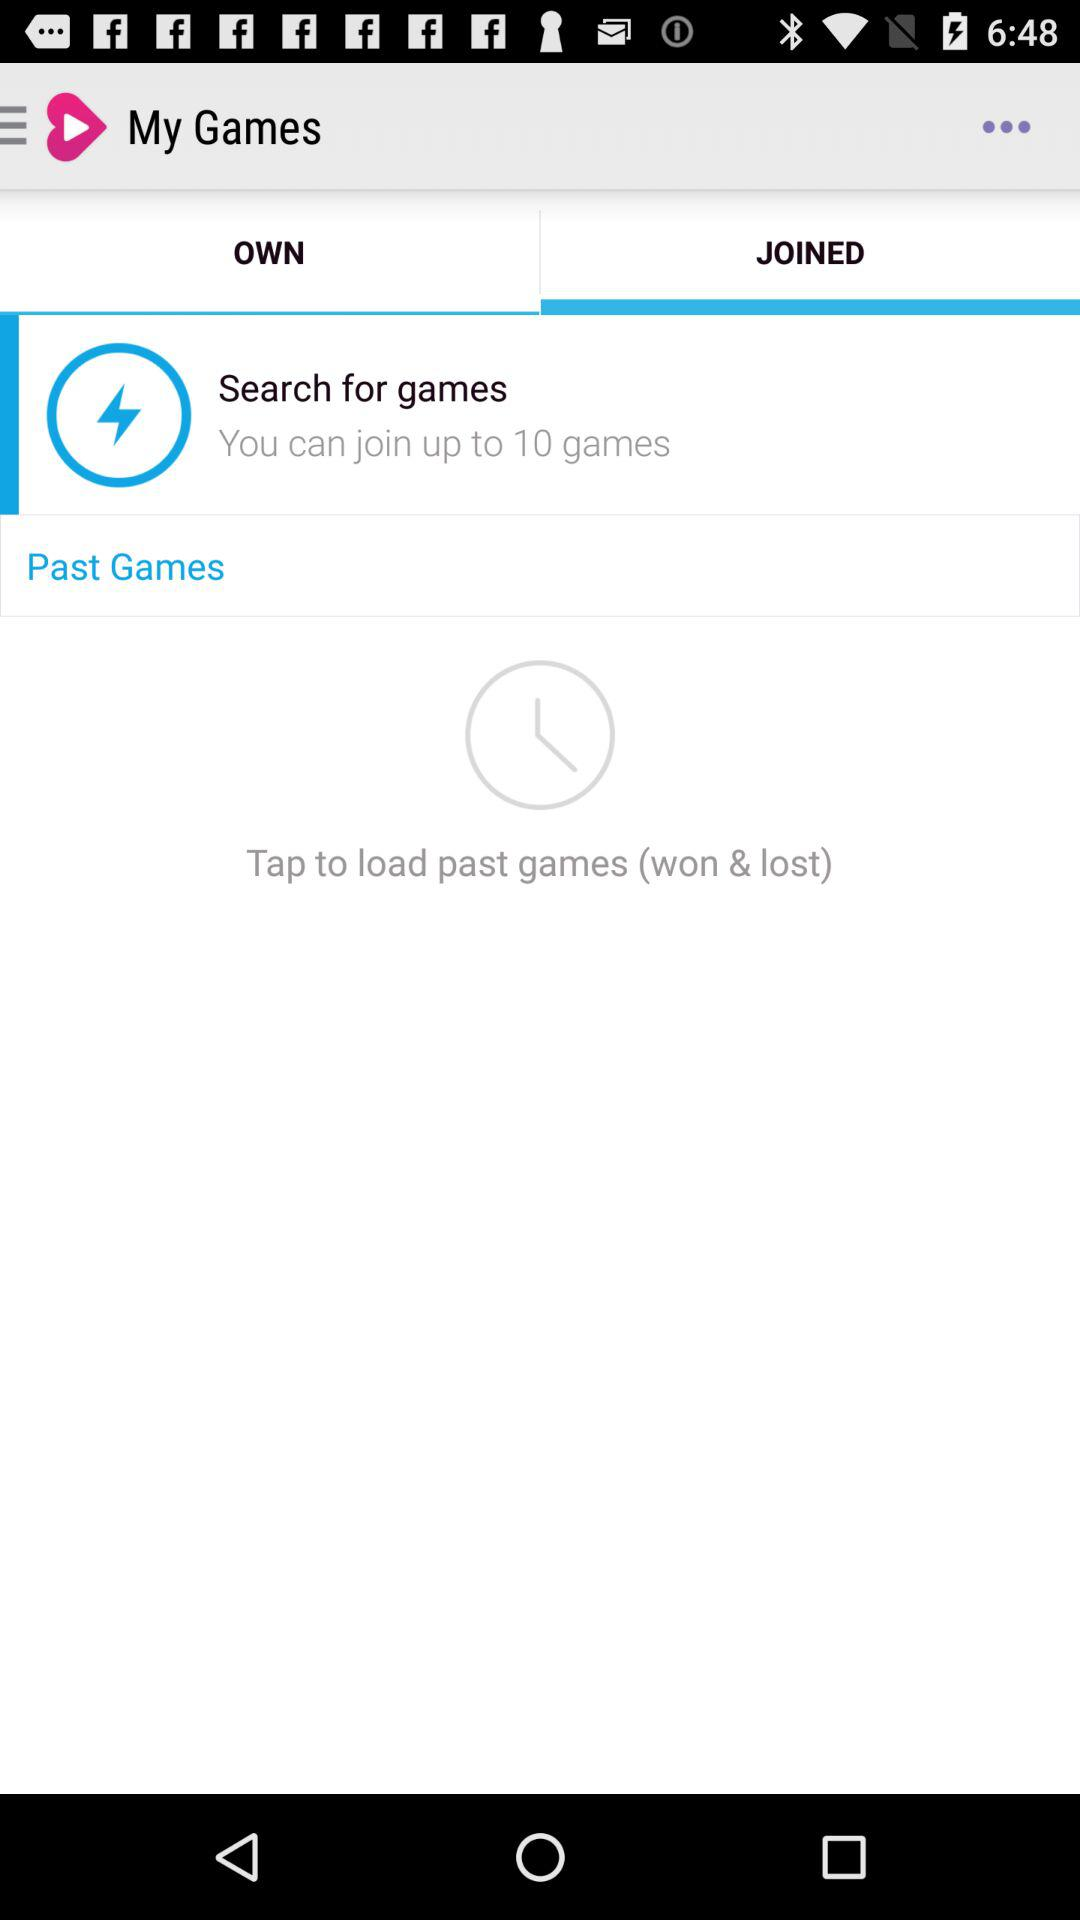How many more games can I join than I own?
Answer the question using a single word or phrase. 10 